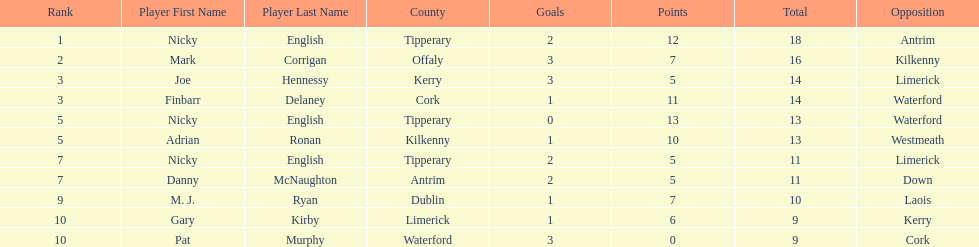What player got 10 total points in their game? M. J. Ryan. 